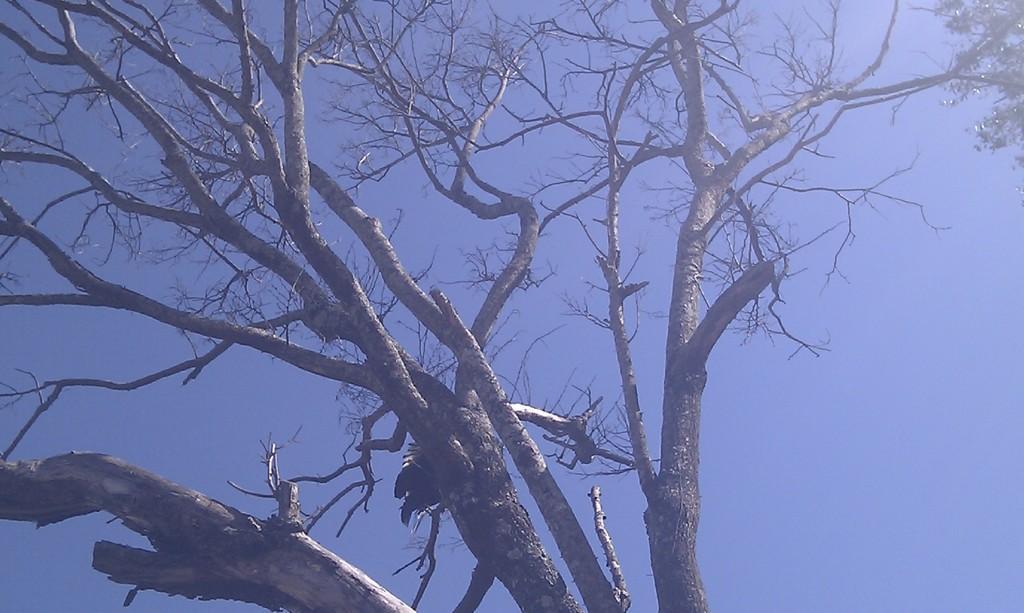Can you describe this image briefly? In this picture there is a tree and there are no leaves on the tree. On the right side of the image there is a tree with leaves. At the top there is sky. 